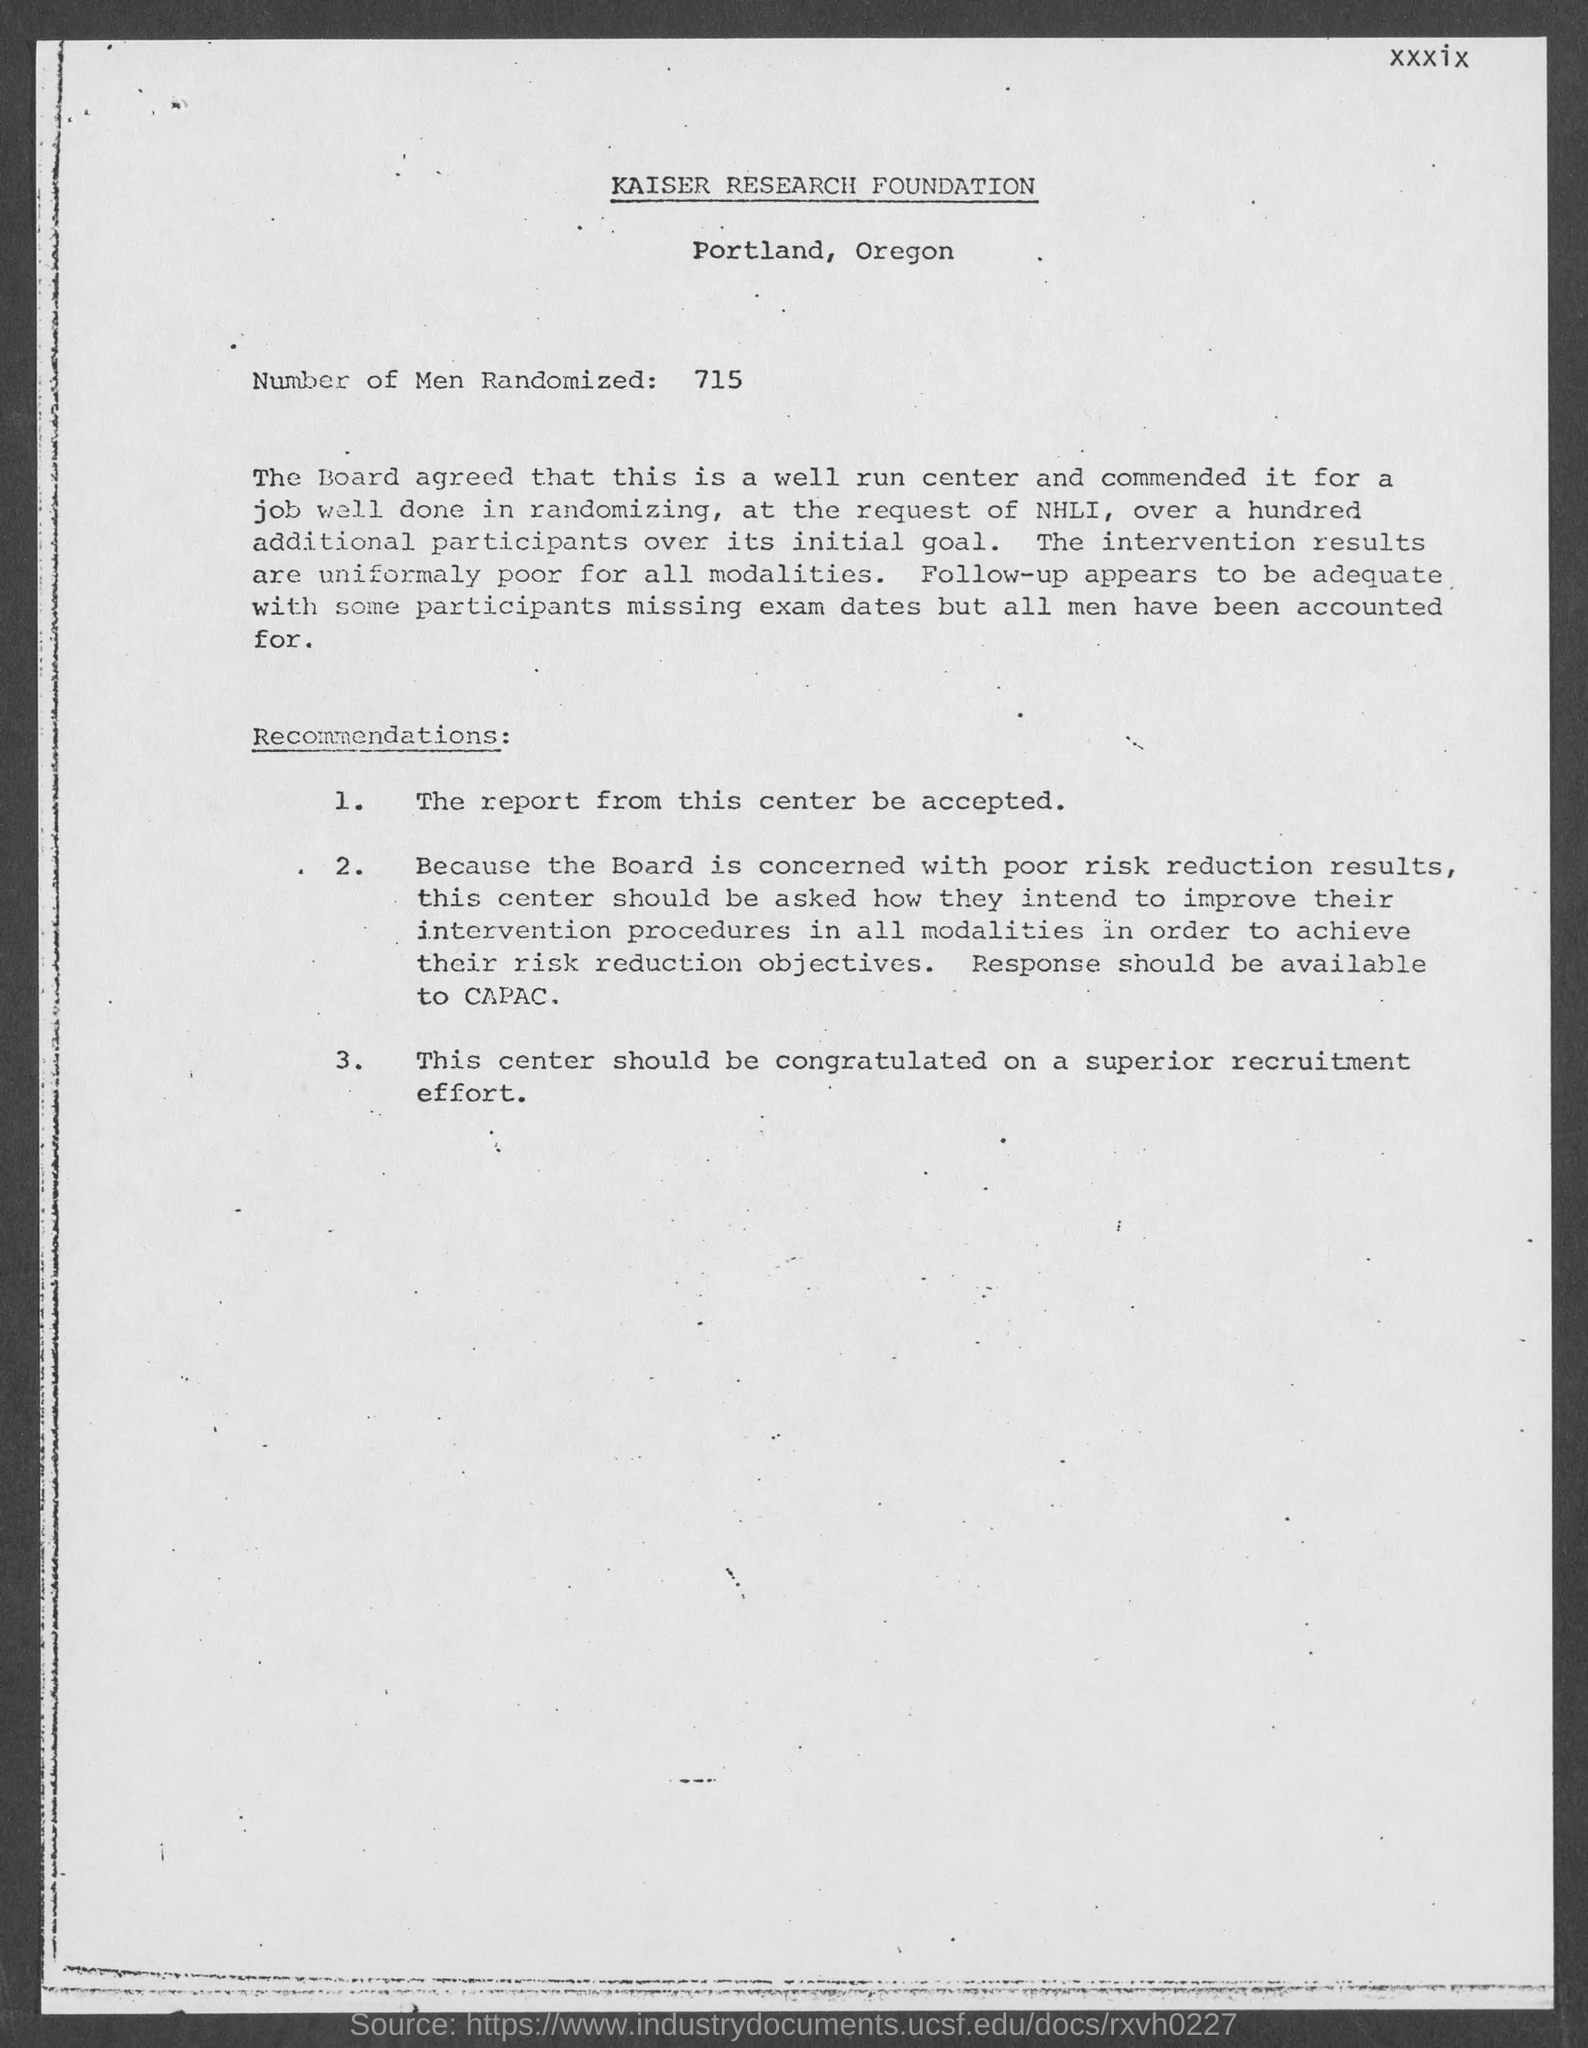How many number of men are randomized ?
Provide a short and direct response. 715. 